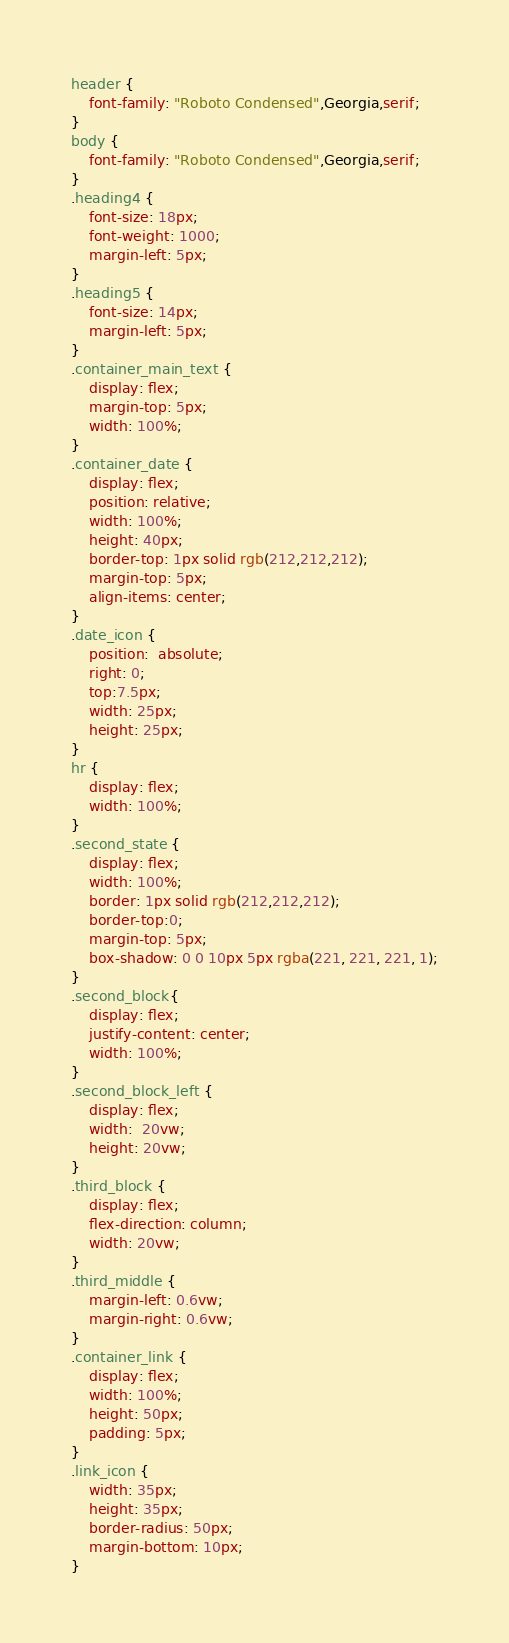<code> <loc_0><loc_0><loc_500><loc_500><_CSS_>header {
	font-family: "Roboto Condensed",Georgia,serif;
}
body {
	font-family: "Roboto Condensed",Georgia,serif;
}
.heading4 {
    font-size: 18px;
    font-weight: 1000;
    margin-left: 5px;
}
.heading5 {
    font-size: 14px;
    margin-left: 5px;
}
.container_main_text {
    display: flex;
    margin-top: 5px;
    width: 100%; 
}
.container_date {
    display: flex;
    position: relative;
    width: 100%;
    height: 40px;
    border-top: 1px solid rgb(212,212,212);
    margin-top: 5px;
    align-items: center;
}
.date_icon {
    position:  absolute;
    right: 0;
    top:7.5px;
    width: 25px;
    height: 25px;
}
hr {
    display: flex;
    width: 100%;
}
.second_state {
    display: flex;  
    width: 100%;
    border: 1px solid rgb(212,212,212);
    border-top:0;
    margin-top: 5px;
    box-shadow: 0 0 10px 5px rgba(221, 221, 221, 1);
}
.second_block{
    display: flex;
    justify-content: center;
    width: 100%;
}
.second_block_left {
    display: flex;
    width:  20vw;
    height: 20vw;
}
.third_block {
    display: flex;
    flex-direction: column;
    width: 20vw;
}
.third_middle {
    margin-left: 0.6vw;
    margin-right: 0.6vw;
}
.container_link {
    display: flex;
    width: 100%;
    height: 50px;
    padding: 5px;
}
.link_icon {
    width: 35px;
    height: 35px;
    border-radius: 50px;
    margin-bottom: 10px;
}</code> 